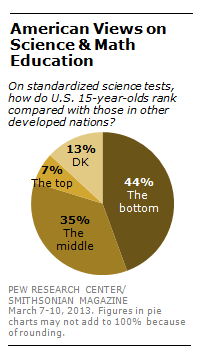List a handful of essential elements in this visual. The largest section is 44. The total sum value of the largest two segments is 79. 